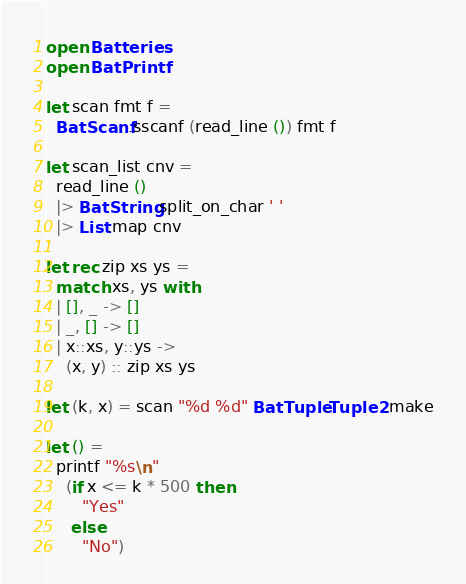Convert code to text. <code><loc_0><loc_0><loc_500><loc_500><_OCaml_>open Batteries
open BatPrintf

let scan fmt f =
  BatScanf.sscanf (read_line ()) fmt f

let scan_list cnv =
  read_line ()
  |> BatString.split_on_char ' '
  |> List.map cnv

let rec zip xs ys =
  match xs, ys with
  | [], _ -> []
  | _, [] -> []
  | x::xs, y::ys ->
    (x, y) :: zip xs ys

let (k, x) = scan "%d %d" BatTuple.Tuple2.make

let () =
  printf "%s\n"
    (if x <= k * 500 then
       "Yes"
     else
       "No")
</code> 